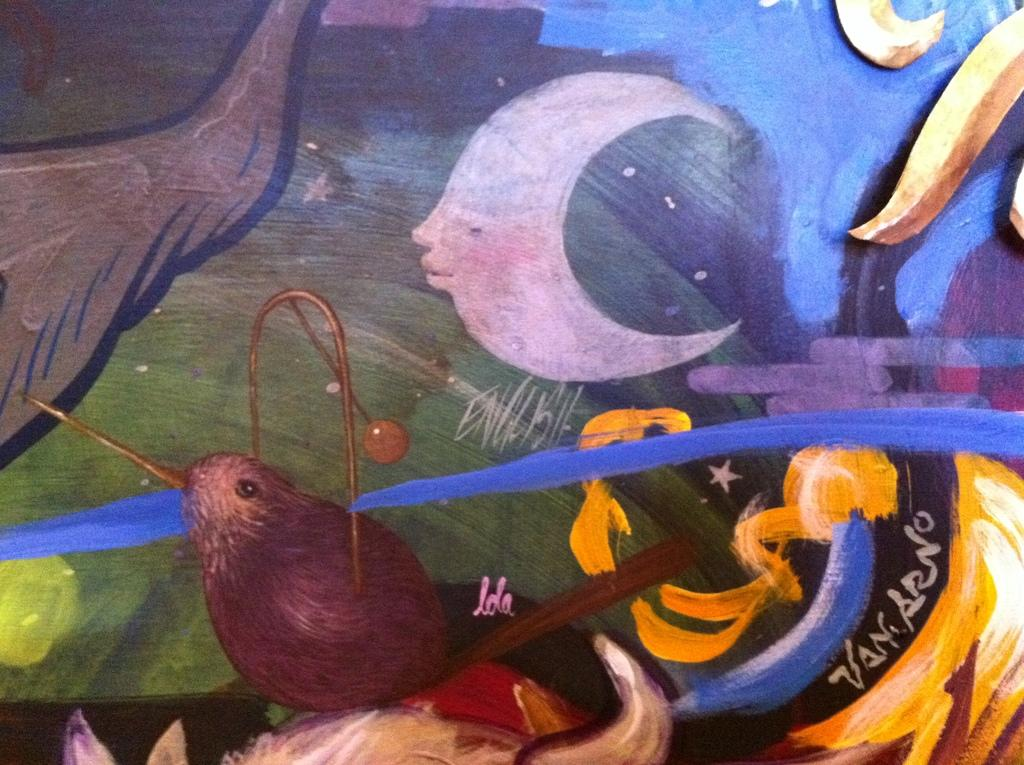What is the main subject of the image? The main subject of the image is a painting. Can you describe any text or words in the image? Yes, there are words on an object in the image. What type of flowers are depicted in the painting? There is no mention of flowers in the image, as the facts only mention a painting and words on an object. 